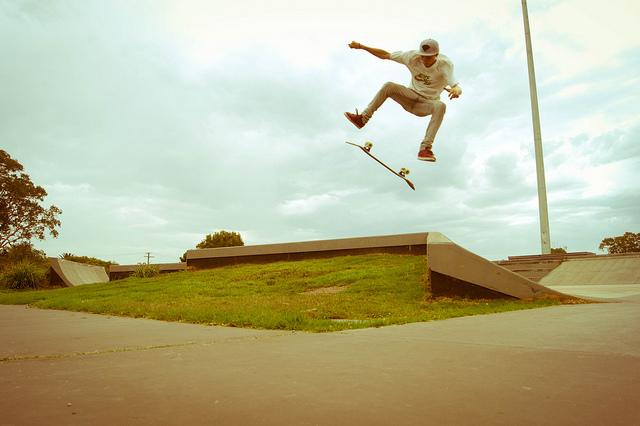Is this skateboarder grinding?
Give a very brief answer. No. What color are his shoes?
Answer briefly. Red. Is this person skateboarding on a regulation half pipe?
Short answer required. No. What color are the men's shoes?
Give a very brief answer. Red. Can the person land on the skateboard safely in the position it is currently in?
Keep it brief. No. Is he going to hurt himself?
Keep it brief. No. 